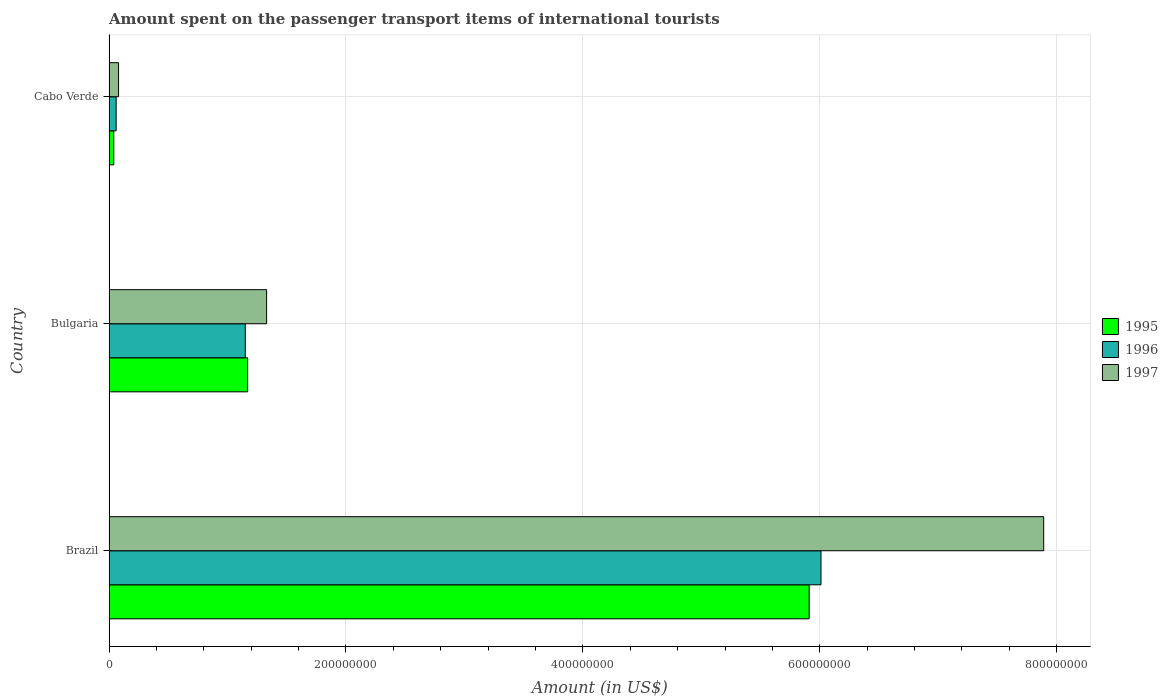How many different coloured bars are there?
Your answer should be compact. 3. How many groups of bars are there?
Ensure brevity in your answer.  3. Are the number of bars per tick equal to the number of legend labels?
Provide a short and direct response. Yes. How many bars are there on the 1st tick from the bottom?
Offer a terse response. 3. What is the label of the 2nd group of bars from the top?
Your response must be concise. Bulgaria. In how many cases, is the number of bars for a given country not equal to the number of legend labels?
Keep it short and to the point. 0. What is the amount spent on the passenger transport items of international tourists in 1995 in Brazil?
Your answer should be compact. 5.91e+08. Across all countries, what is the maximum amount spent on the passenger transport items of international tourists in 1997?
Make the answer very short. 7.89e+08. Across all countries, what is the minimum amount spent on the passenger transport items of international tourists in 1997?
Your answer should be compact. 8.00e+06. In which country was the amount spent on the passenger transport items of international tourists in 1997 minimum?
Offer a terse response. Cabo Verde. What is the total amount spent on the passenger transport items of international tourists in 1995 in the graph?
Ensure brevity in your answer.  7.12e+08. What is the difference between the amount spent on the passenger transport items of international tourists in 1995 in Bulgaria and that in Cabo Verde?
Offer a very short reply. 1.13e+08. What is the difference between the amount spent on the passenger transport items of international tourists in 1996 in Cabo Verde and the amount spent on the passenger transport items of international tourists in 1997 in Brazil?
Provide a succinct answer. -7.83e+08. What is the average amount spent on the passenger transport items of international tourists in 1996 per country?
Give a very brief answer. 2.41e+08. What is the ratio of the amount spent on the passenger transport items of international tourists in 1996 in Brazil to that in Bulgaria?
Your answer should be compact. 5.23. Is the difference between the amount spent on the passenger transport items of international tourists in 1995 in Brazil and Cabo Verde greater than the difference between the amount spent on the passenger transport items of international tourists in 1996 in Brazil and Cabo Verde?
Give a very brief answer. No. What is the difference between the highest and the second highest amount spent on the passenger transport items of international tourists in 1996?
Give a very brief answer. 4.86e+08. What is the difference between the highest and the lowest amount spent on the passenger transport items of international tourists in 1995?
Offer a very short reply. 5.87e+08. In how many countries, is the amount spent on the passenger transport items of international tourists in 1995 greater than the average amount spent on the passenger transport items of international tourists in 1995 taken over all countries?
Your response must be concise. 1. Is the sum of the amount spent on the passenger transport items of international tourists in 1997 in Brazil and Cabo Verde greater than the maximum amount spent on the passenger transport items of international tourists in 1996 across all countries?
Make the answer very short. Yes. What does the 1st bar from the bottom in Cabo Verde represents?
Provide a short and direct response. 1995. Is it the case that in every country, the sum of the amount spent on the passenger transport items of international tourists in 1995 and amount spent on the passenger transport items of international tourists in 1996 is greater than the amount spent on the passenger transport items of international tourists in 1997?
Your answer should be very brief. Yes. How many bars are there?
Ensure brevity in your answer.  9. What is the difference between two consecutive major ticks on the X-axis?
Make the answer very short. 2.00e+08. Does the graph contain any zero values?
Provide a succinct answer. No. Does the graph contain grids?
Provide a succinct answer. Yes. What is the title of the graph?
Make the answer very short. Amount spent on the passenger transport items of international tourists. What is the Amount (in US$) of 1995 in Brazil?
Your answer should be compact. 5.91e+08. What is the Amount (in US$) of 1996 in Brazil?
Make the answer very short. 6.01e+08. What is the Amount (in US$) of 1997 in Brazil?
Keep it short and to the point. 7.89e+08. What is the Amount (in US$) of 1995 in Bulgaria?
Your answer should be compact. 1.17e+08. What is the Amount (in US$) of 1996 in Bulgaria?
Keep it short and to the point. 1.15e+08. What is the Amount (in US$) in 1997 in Bulgaria?
Give a very brief answer. 1.33e+08. What is the Amount (in US$) in 1995 in Cabo Verde?
Provide a short and direct response. 4.00e+06. What is the Amount (in US$) in 1996 in Cabo Verde?
Your response must be concise. 6.00e+06. Across all countries, what is the maximum Amount (in US$) of 1995?
Keep it short and to the point. 5.91e+08. Across all countries, what is the maximum Amount (in US$) of 1996?
Ensure brevity in your answer.  6.01e+08. Across all countries, what is the maximum Amount (in US$) in 1997?
Ensure brevity in your answer.  7.89e+08. Across all countries, what is the minimum Amount (in US$) of 1996?
Offer a very short reply. 6.00e+06. Across all countries, what is the minimum Amount (in US$) of 1997?
Your answer should be compact. 8.00e+06. What is the total Amount (in US$) in 1995 in the graph?
Offer a terse response. 7.12e+08. What is the total Amount (in US$) of 1996 in the graph?
Give a very brief answer. 7.22e+08. What is the total Amount (in US$) in 1997 in the graph?
Ensure brevity in your answer.  9.30e+08. What is the difference between the Amount (in US$) of 1995 in Brazil and that in Bulgaria?
Your answer should be compact. 4.74e+08. What is the difference between the Amount (in US$) in 1996 in Brazil and that in Bulgaria?
Your answer should be very brief. 4.86e+08. What is the difference between the Amount (in US$) in 1997 in Brazil and that in Bulgaria?
Your answer should be compact. 6.56e+08. What is the difference between the Amount (in US$) in 1995 in Brazil and that in Cabo Verde?
Your answer should be very brief. 5.87e+08. What is the difference between the Amount (in US$) in 1996 in Brazil and that in Cabo Verde?
Your answer should be very brief. 5.95e+08. What is the difference between the Amount (in US$) of 1997 in Brazil and that in Cabo Verde?
Your answer should be compact. 7.81e+08. What is the difference between the Amount (in US$) of 1995 in Bulgaria and that in Cabo Verde?
Your answer should be very brief. 1.13e+08. What is the difference between the Amount (in US$) in 1996 in Bulgaria and that in Cabo Verde?
Ensure brevity in your answer.  1.09e+08. What is the difference between the Amount (in US$) in 1997 in Bulgaria and that in Cabo Verde?
Offer a very short reply. 1.25e+08. What is the difference between the Amount (in US$) in 1995 in Brazil and the Amount (in US$) in 1996 in Bulgaria?
Give a very brief answer. 4.76e+08. What is the difference between the Amount (in US$) of 1995 in Brazil and the Amount (in US$) of 1997 in Bulgaria?
Offer a terse response. 4.58e+08. What is the difference between the Amount (in US$) in 1996 in Brazil and the Amount (in US$) in 1997 in Bulgaria?
Provide a succinct answer. 4.68e+08. What is the difference between the Amount (in US$) of 1995 in Brazil and the Amount (in US$) of 1996 in Cabo Verde?
Your answer should be compact. 5.85e+08. What is the difference between the Amount (in US$) of 1995 in Brazil and the Amount (in US$) of 1997 in Cabo Verde?
Give a very brief answer. 5.83e+08. What is the difference between the Amount (in US$) of 1996 in Brazil and the Amount (in US$) of 1997 in Cabo Verde?
Give a very brief answer. 5.93e+08. What is the difference between the Amount (in US$) in 1995 in Bulgaria and the Amount (in US$) in 1996 in Cabo Verde?
Ensure brevity in your answer.  1.11e+08. What is the difference between the Amount (in US$) of 1995 in Bulgaria and the Amount (in US$) of 1997 in Cabo Verde?
Provide a short and direct response. 1.09e+08. What is the difference between the Amount (in US$) in 1996 in Bulgaria and the Amount (in US$) in 1997 in Cabo Verde?
Keep it short and to the point. 1.07e+08. What is the average Amount (in US$) of 1995 per country?
Your response must be concise. 2.37e+08. What is the average Amount (in US$) in 1996 per country?
Your response must be concise. 2.41e+08. What is the average Amount (in US$) of 1997 per country?
Your answer should be very brief. 3.10e+08. What is the difference between the Amount (in US$) in 1995 and Amount (in US$) in 1996 in Brazil?
Offer a very short reply. -1.00e+07. What is the difference between the Amount (in US$) in 1995 and Amount (in US$) in 1997 in Brazil?
Give a very brief answer. -1.98e+08. What is the difference between the Amount (in US$) in 1996 and Amount (in US$) in 1997 in Brazil?
Ensure brevity in your answer.  -1.88e+08. What is the difference between the Amount (in US$) in 1995 and Amount (in US$) in 1996 in Bulgaria?
Your response must be concise. 2.00e+06. What is the difference between the Amount (in US$) of 1995 and Amount (in US$) of 1997 in Bulgaria?
Your response must be concise. -1.60e+07. What is the difference between the Amount (in US$) of 1996 and Amount (in US$) of 1997 in Bulgaria?
Keep it short and to the point. -1.80e+07. What is the difference between the Amount (in US$) of 1995 and Amount (in US$) of 1997 in Cabo Verde?
Keep it short and to the point. -4.00e+06. What is the ratio of the Amount (in US$) in 1995 in Brazil to that in Bulgaria?
Offer a terse response. 5.05. What is the ratio of the Amount (in US$) in 1996 in Brazil to that in Bulgaria?
Your answer should be very brief. 5.23. What is the ratio of the Amount (in US$) of 1997 in Brazil to that in Bulgaria?
Ensure brevity in your answer.  5.93. What is the ratio of the Amount (in US$) in 1995 in Brazil to that in Cabo Verde?
Provide a succinct answer. 147.75. What is the ratio of the Amount (in US$) of 1996 in Brazil to that in Cabo Verde?
Make the answer very short. 100.17. What is the ratio of the Amount (in US$) in 1997 in Brazil to that in Cabo Verde?
Offer a very short reply. 98.62. What is the ratio of the Amount (in US$) in 1995 in Bulgaria to that in Cabo Verde?
Keep it short and to the point. 29.25. What is the ratio of the Amount (in US$) of 1996 in Bulgaria to that in Cabo Verde?
Your response must be concise. 19.17. What is the ratio of the Amount (in US$) in 1997 in Bulgaria to that in Cabo Verde?
Provide a short and direct response. 16.62. What is the difference between the highest and the second highest Amount (in US$) in 1995?
Keep it short and to the point. 4.74e+08. What is the difference between the highest and the second highest Amount (in US$) in 1996?
Offer a very short reply. 4.86e+08. What is the difference between the highest and the second highest Amount (in US$) in 1997?
Make the answer very short. 6.56e+08. What is the difference between the highest and the lowest Amount (in US$) of 1995?
Your response must be concise. 5.87e+08. What is the difference between the highest and the lowest Amount (in US$) in 1996?
Your response must be concise. 5.95e+08. What is the difference between the highest and the lowest Amount (in US$) of 1997?
Ensure brevity in your answer.  7.81e+08. 